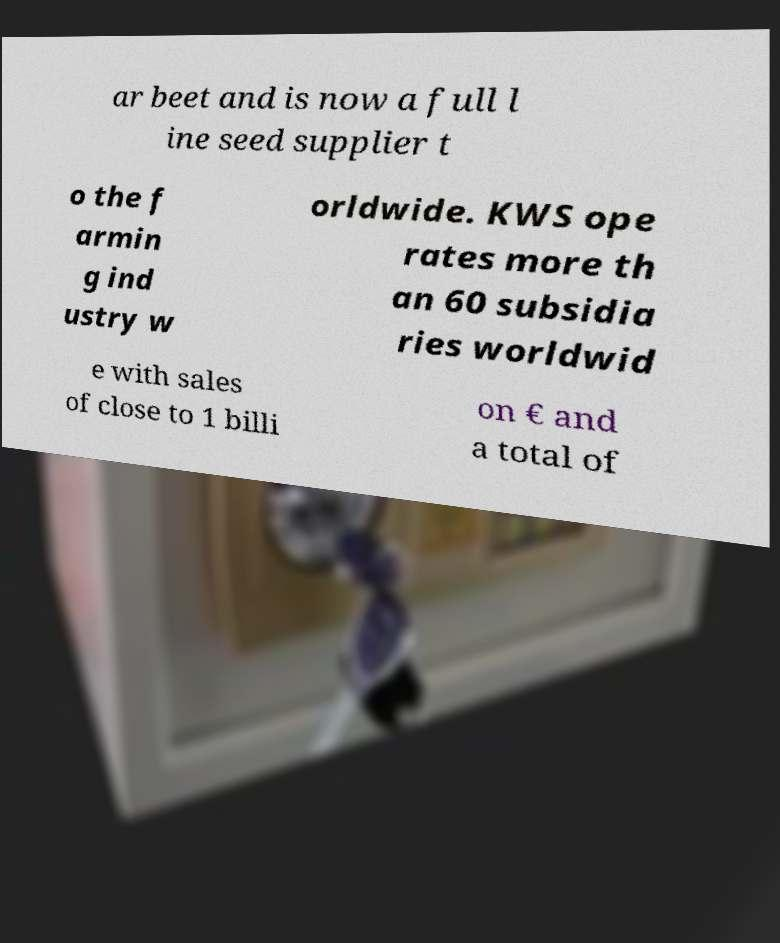Please read and relay the text visible in this image. What does it say? ar beet and is now a full l ine seed supplier t o the f armin g ind ustry w orldwide. KWS ope rates more th an 60 subsidia ries worldwid e with sales of close to 1 billi on € and a total of 